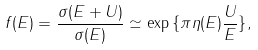<formula> <loc_0><loc_0><loc_500><loc_500>f ( E ) = \frac { \sigma ( E + U ) } { \sigma ( E ) } \simeq \exp { \{ \pi \eta ( E ) \frac { U } { E } \} } ,</formula> 